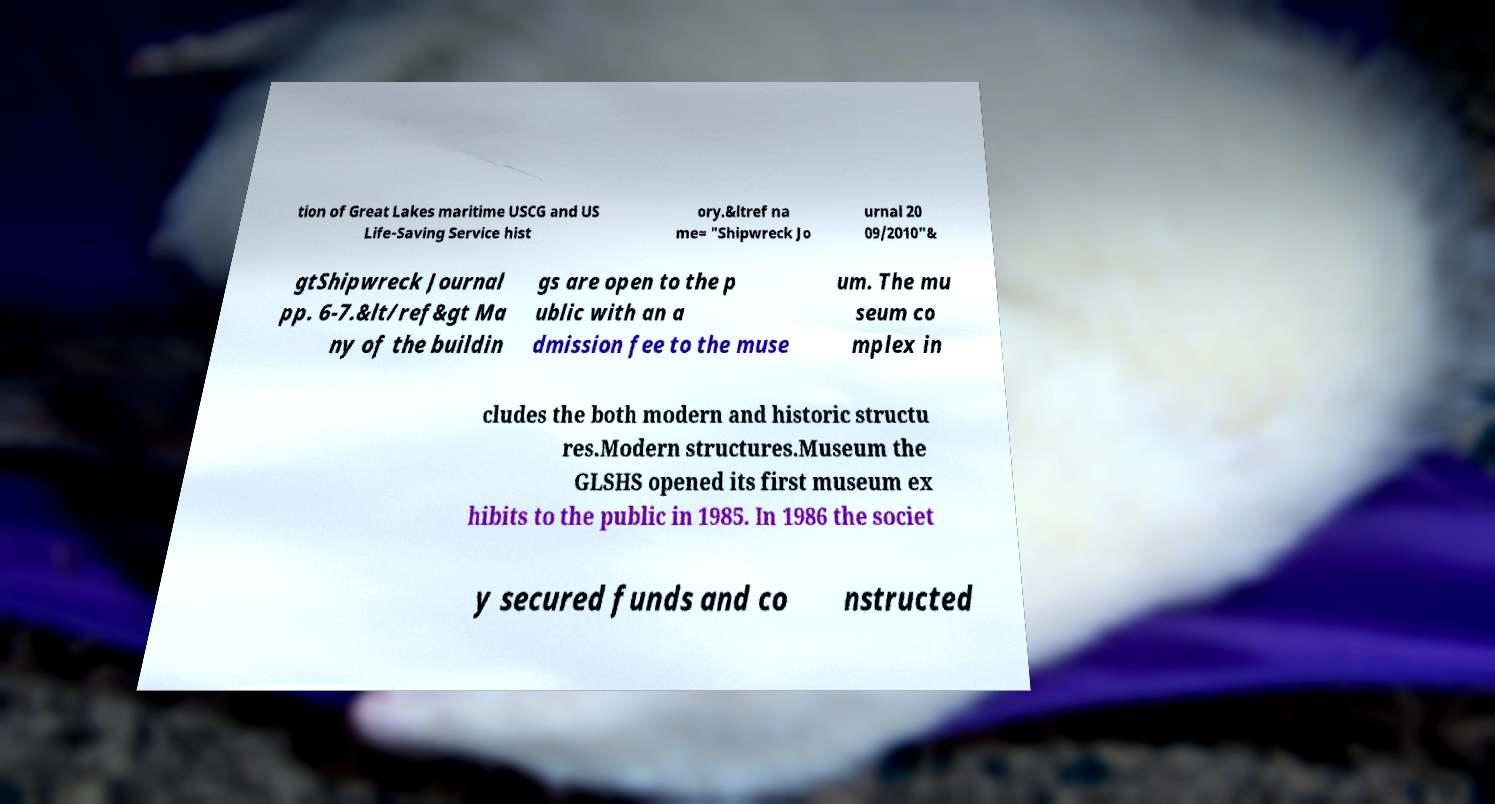Can you accurately transcribe the text from the provided image for me? tion of Great Lakes maritime USCG and US Life-Saving Service hist ory.&ltref na me= "Shipwreck Jo urnal 20 09/2010"& gtShipwreck Journal pp. 6-7.&lt/ref&gt Ma ny of the buildin gs are open to the p ublic with an a dmission fee to the muse um. The mu seum co mplex in cludes the both modern and historic structu res.Modern structures.Museum the GLSHS opened its first museum ex hibits to the public in 1985. In 1986 the societ y secured funds and co nstructed 